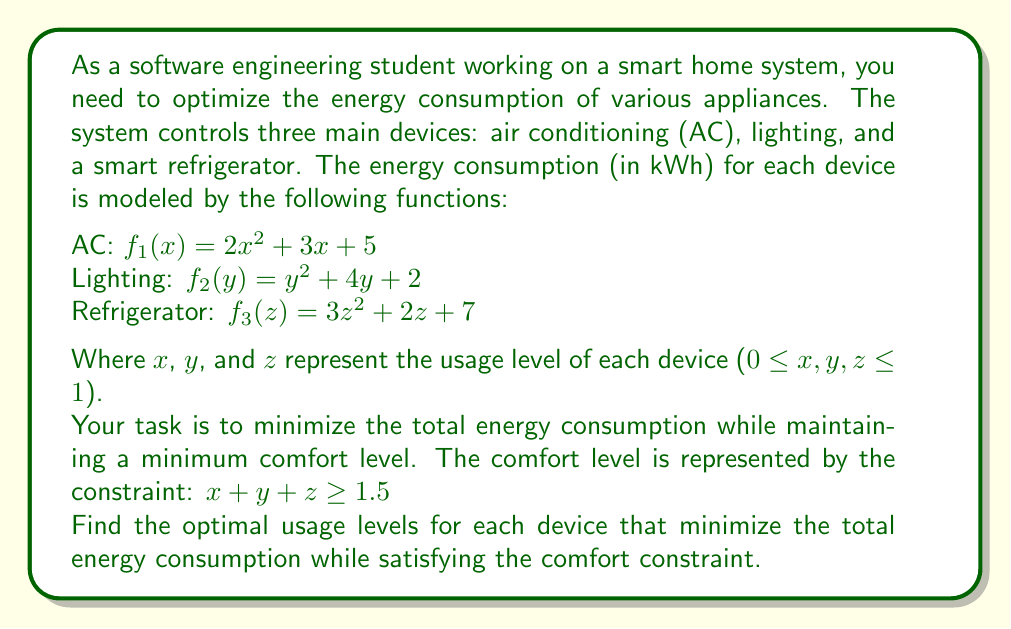Solve this math problem. To solve this optimization problem, we'll use the method of Lagrange multipliers. Let's follow these steps:

1) First, we define the objective function as the sum of energy consumption for all devices:
   $$F(x,y,z) = f_1(x) + f_2(y) + f_3(z) = (2x^2 + 3x + 5) + (y^2 + 4y + 2) + (3z^2 + 2z + 7)$$

2) The constraint function is:
   $$g(x,y,z) = x + y + z - 1.5 = 0$$

3) We form the Lagrangian function:
   $$L(x,y,z,λ) = F(x,y,z) - λg(x,y,z)$$
   $$L(x,y,z,λ) = (2x^2 + 3x + 5) + (y^2 + 4y + 2) + (3z^2 + 2z + 7) - λ(x + y + z - 1.5)$$

4) We take partial derivatives and set them to zero:
   $$\frac{\partial L}{\partial x} = 4x + 3 - λ = 0$$
   $$\frac{\partial L}{\partial y} = 2y + 4 - λ = 0$$
   $$\frac{\partial L}{\partial z} = 6z + 2 - λ = 0$$
   $$\frac{\partial L}{\partial λ} = x + y + z - 1.5 = 0$$

5) From these equations, we can derive:
   $$x = \frac{λ - 3}{4}$$
   $$y = \frac{λ - 4}{2}$$
   $$z = \frac{λ - 2}{6}$$

6) Substituting these into the constraint equation:
   $$\frac{λ - 3}{4} + \frac{λ - 4}{2} + \frac{λ - 2}{6} = 1.5$$

7) Solving this equation:
   $$\frac{3λ - 9}{12} + \frac{3λ - 12}{6} + \frac{λ - 2}{6} = 1.5$$
   $$\frac{9λ - 27 + 18λ - 72 + 2λ - 4}{12} = 1.5$$
   $$\frac{29λ - 103}{12} = 1.5$$
   $$29λ - 103 = 18$$
   $$29λ = 121$$
   $$λ = \frac{121}{29}$$

8) Now we can calculate x, y, and z:
   $$x = \frac{\frac{121}{29} - 3}{4} = \frac{121 - 87}{116} = \frac{34}{116} ≈ 0.293$$
   $$y = \frac{\frac{121}{29} - 4}{2} = \frac{121 - 116}{58} = \frac{5}{58} ≈ 0.086$$
   $$z = \frac{\frac{121}{29} - 2}{6} = \frac{121 - 58}{174} = \frac{63}{174} ≈ 0.362$$

These values satisfy the constraint: 0.293 + 0.086 + 0.362 ≈ 0.741 + 0.741 ≈ 1.5
Answer: The optimal usage levels that minimize energy consumption while satisfying the comfort constraint are:
AC: $x ≈ 0.293$
Lighting: $y ≈ 0.086$
Refrigerator: $z ≈ 0.362$ 